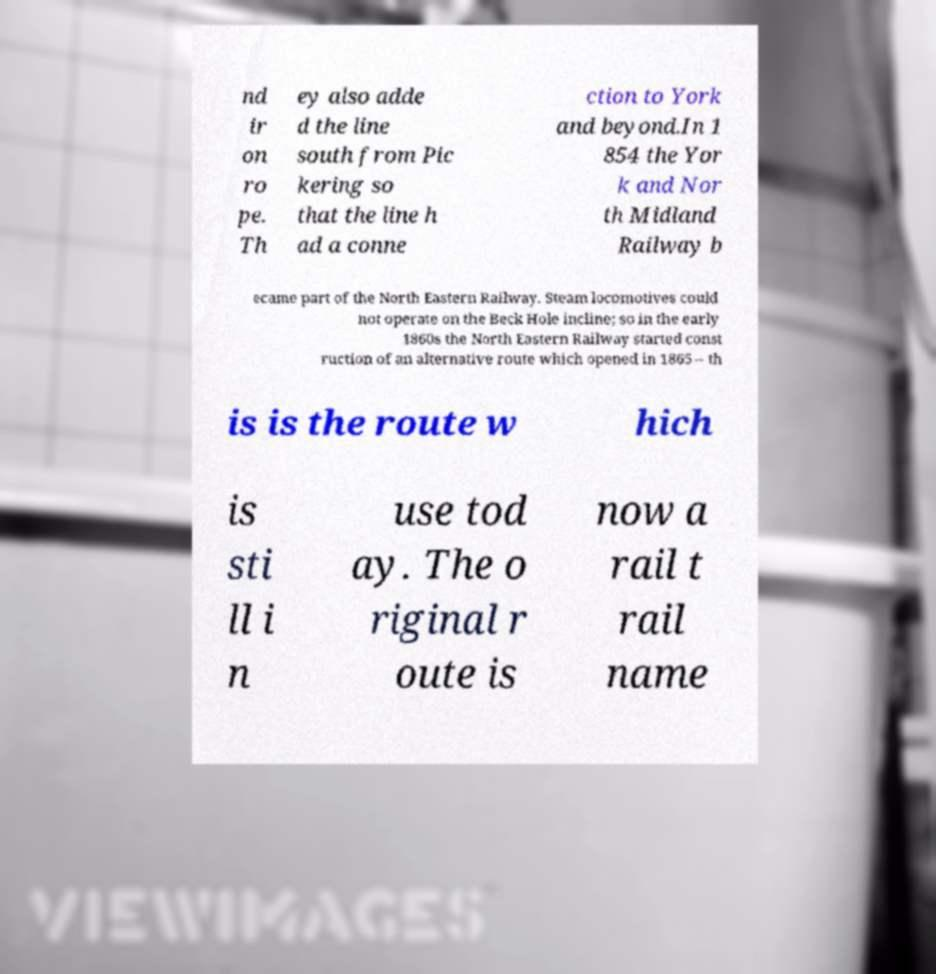There's text embedded in this image that I need extracted. Can you transcribe it verbatim? nd ir on ro pe. Th ey also adde d the line south from Pic kering so that the line h ad a conne ction to York and beyond.In 1 854 the Yor k and Nor th Midland Railway b ecame part of the North Eastern Railway. Steam locomotives could not operate on the Beck Hole incline; so in the early 1860s the North Eastern Railway started const ruction of an alternative route which opened in 1865 – th is is the route w hich is sti ll i n use tod ay. The o riginal r oute is now a rail t rail name 